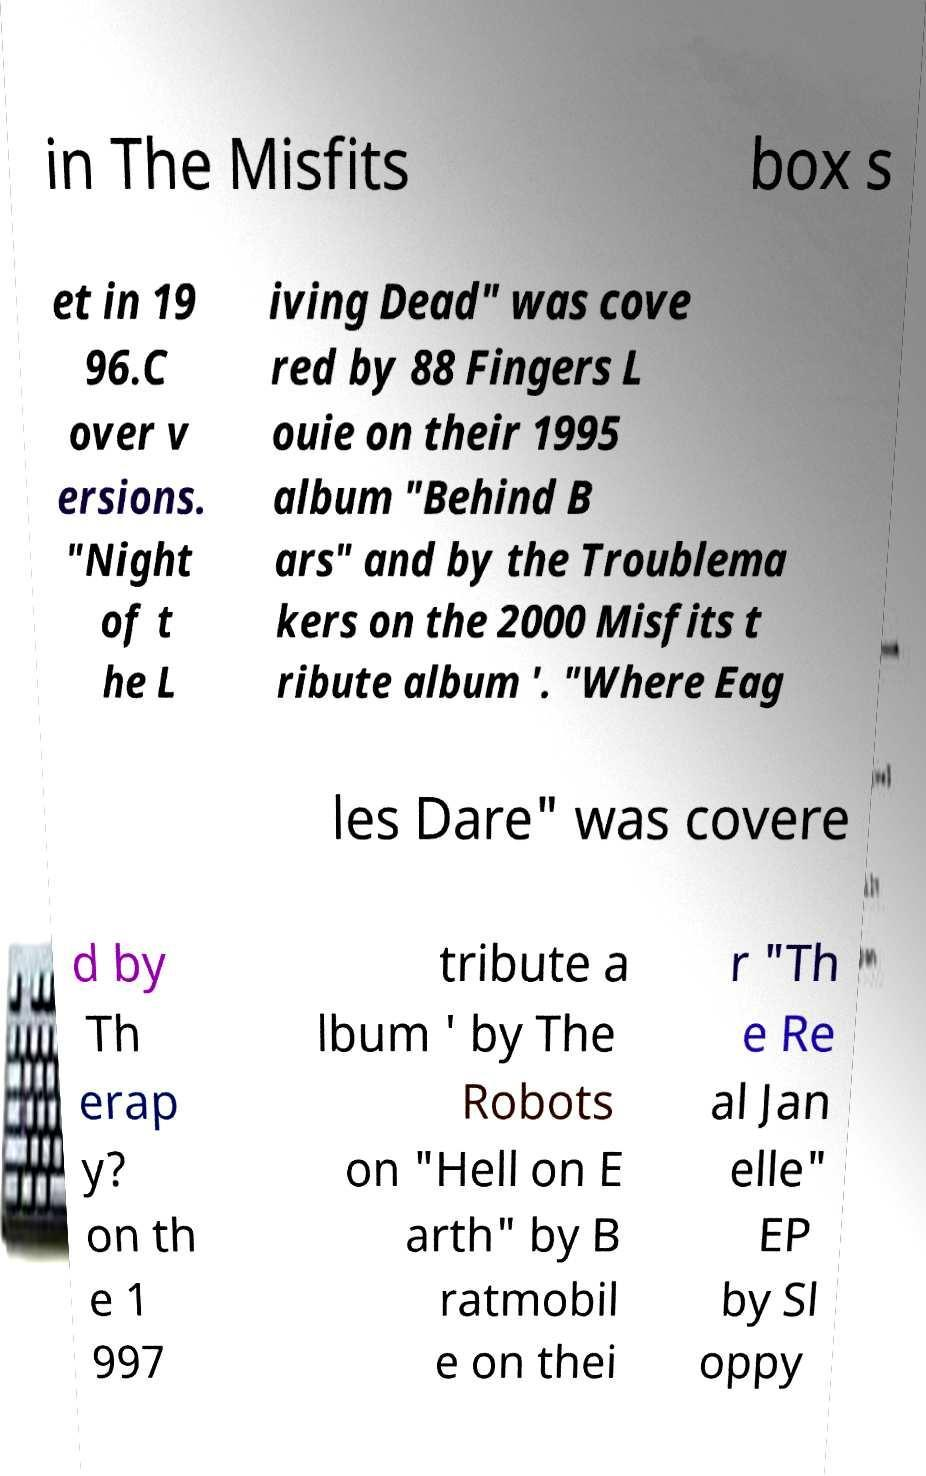Can you read and provide the text displayed in the image?This photo seems to have some interesting text. Can you extract and type it out for me? in The Misfits box s et in 19 96.C over v ersions. "Night of t he L iving Dead" was cove red by 88 Fingers L ouie on their 1995 album "Behind B ars" and by the Troublema kers on the 2000 Misfits t ribute album '. "Where Eag les Dare" was covere d by Th erap y? on th e 1 997 tribute a lbum ' by The Robots on "Hell on E arth" by B ratmobil e on thei r "Th e Re al Jan elle" EP by Sl oppy 